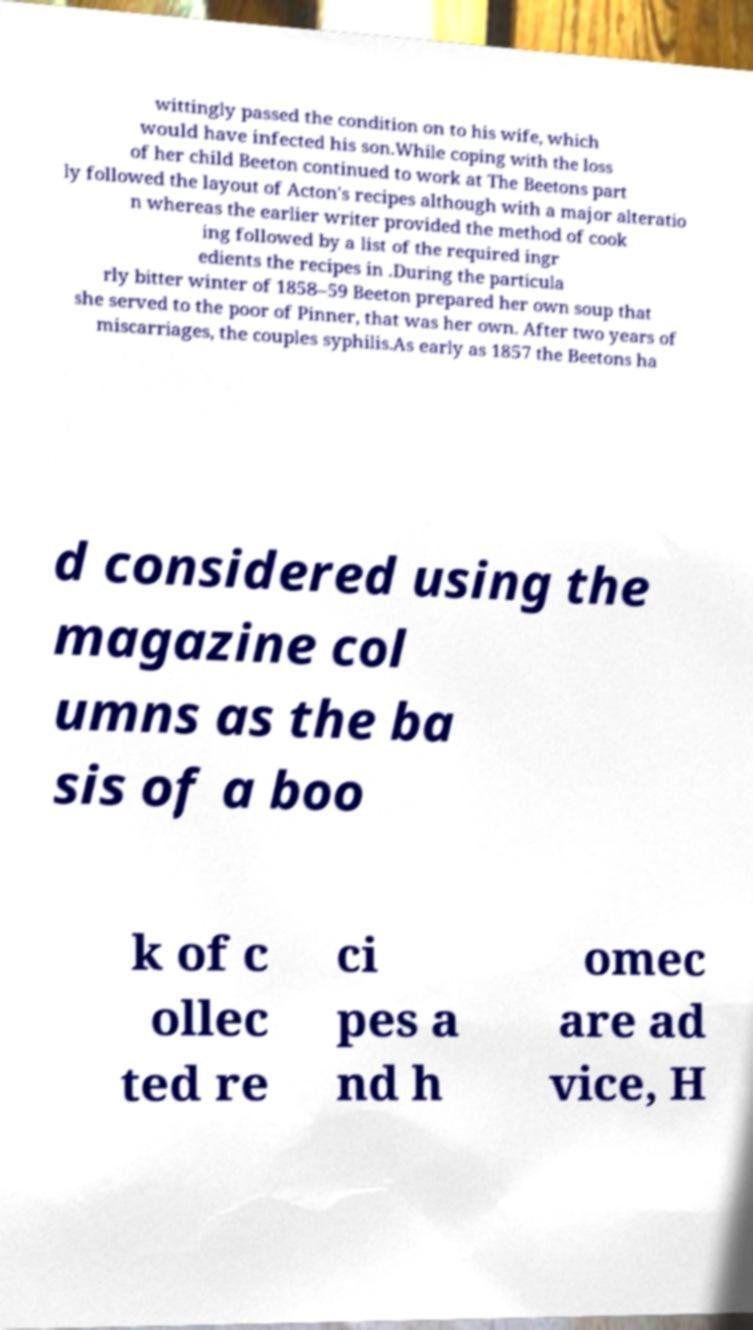Please read and relay the text visible in this image. What does it say? wittingly passed the condition on to his wife, which would have infected his son.While coping with the loss of her child Beeton continued to work at The Beetons part ly followed the layout of Acton's recipes although with a major alteratio n whereas the earlier writer provided the method of cook ing followed by a list of the required ingr edients the recipes in .During the particula rly bitter winter of 1858–59 Beeton prepared her own soup that she served to the poor of Pinner, that was her own. After two years of miscarriages, the couples syphilis.As early as 1857 the Beetons ha d considered using the magazine col umns as the ba sis of a boo k of c ollec ted re ci pes a nd h omec are ad vice, H 